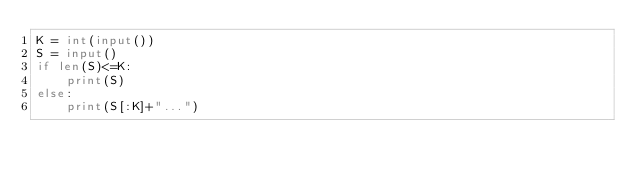Convert code to text. <code><loc_0><loc_0><loc_500><loc_500><_Python_>K = int(input())
S = input()
if len(S)<=K:
    print(S)
else:
    print(S[:K]+"...")
</code> 